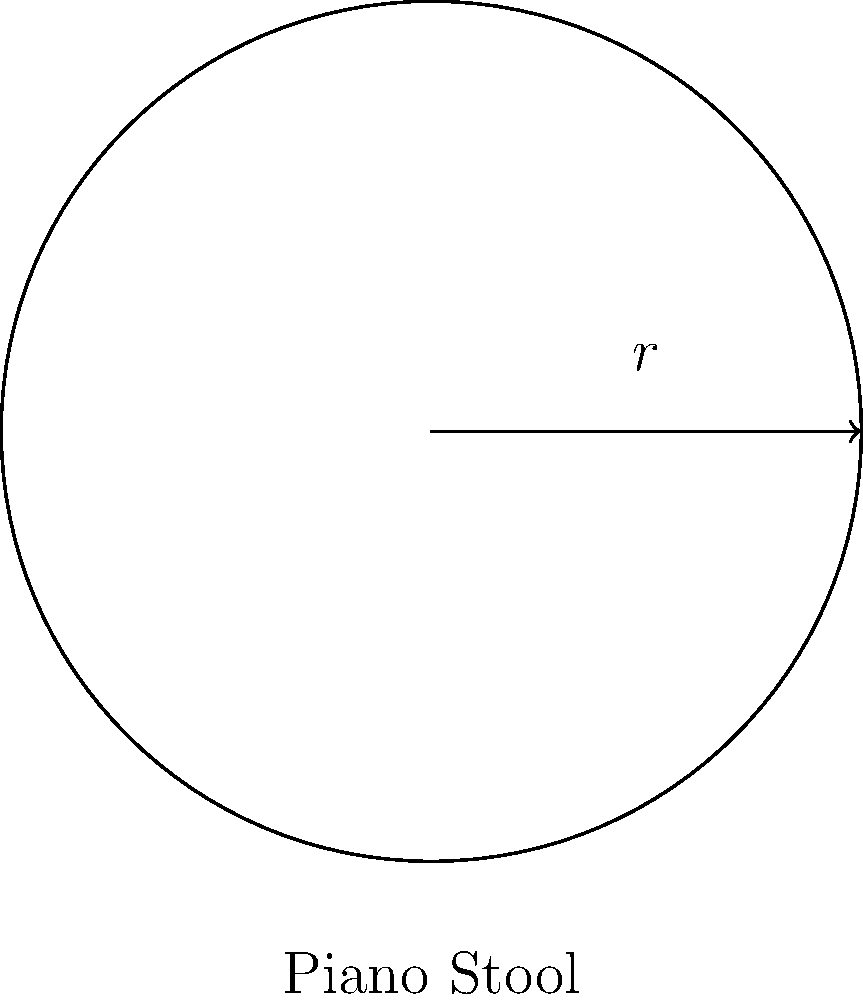As a professional classical piano player, you're considering purchasing a new circular piano stool. The stool has a radius of 30 cm. What is the area of the stool's seat in square centimeters? Use $\pi \approx 3.14$ for your calculations. To find the area of the circular piano stool seat, we need to use the formula for the area of a circle:

$$A = \pi r^2$$

Where:
$A$ = area of the circle
$\pi$ ≈ 3.14 (given approximation)
$r$ = radius of the circle

Given:
Radius ($r$) = 30 cm

Step 1: Substitute the values into the formula.
$$A = \pi r^2$$
$$A = 3.14 \times (30\text{ cm})^2$$

Step 2: Calculate the square of the radius.
$$A = 3.14 \times 900\text{ cm}^2$$

Step 3: Multiply to get the final area.
$$A = 2,826\text{ cm}^2$$

Therefore, the area of the circular piano stool seat is approximately 2,826 square centimeters.
Answer: 2,826 cm² 